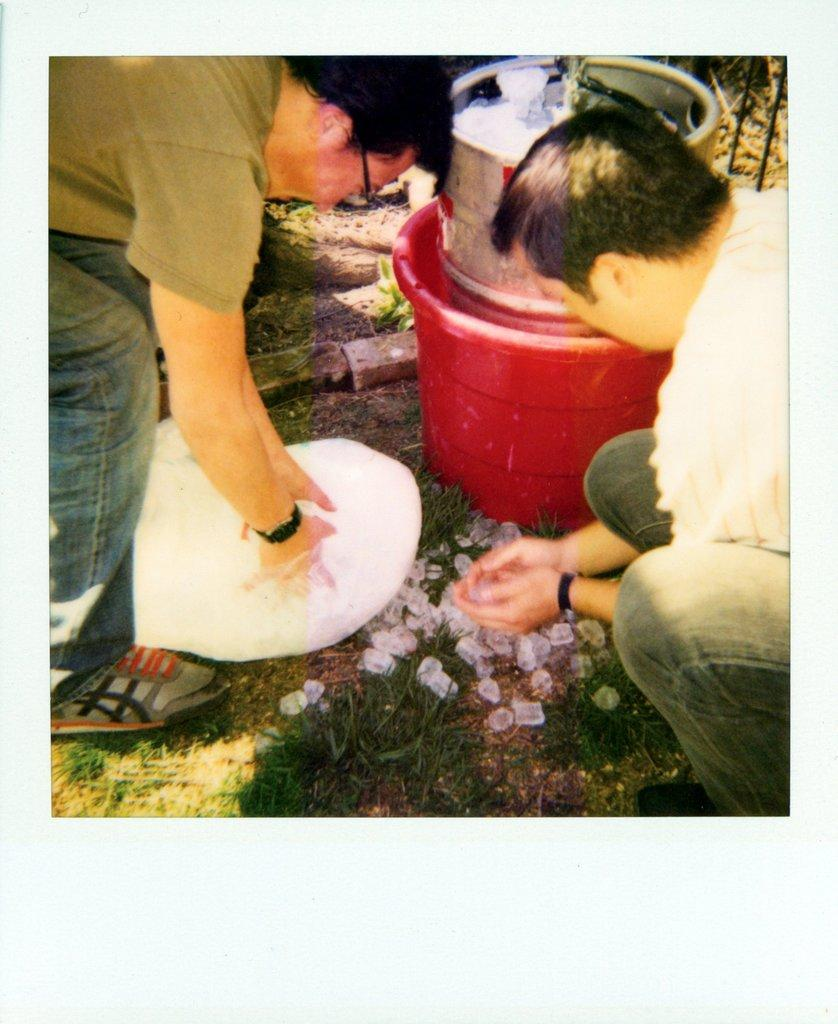How many people are in the image? There are two persons in the image. What are the persons holding in the image? The persons are holding ice cubes. What else can be seen in the image besides the persons? There is a bowl with ice cubes, a bucket, and other bowls in the image. What type of surface is visible in the image? There is grass visible in the image. What type of mitten is the father wearing in the image? There is no father or mitten present in the image. How many visitors can be seen in the image? There are no visitors present in the image; only two persons are visible. 